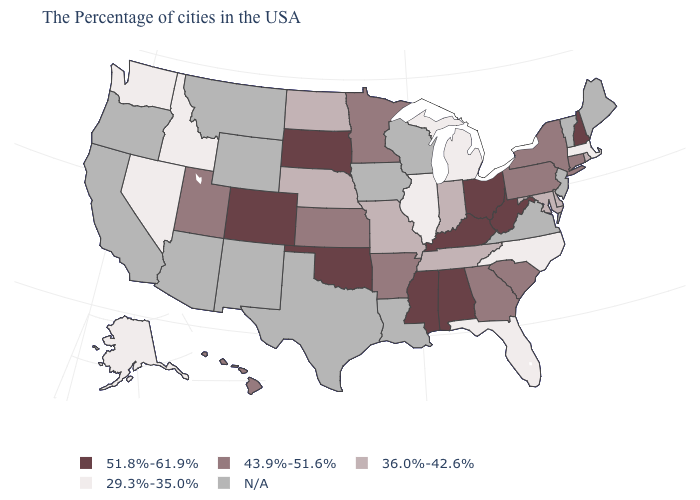Among the states that border South Dakota , does Minnesota have the highest value?
Answer briefly. Yes. What is the value of Ohio?
Keep it brief. 51.8%-61.9%. Does the map have missing data?
Concise answer only. Yes. What is the value of Alaska?
Quick response, please. 29.3%-35.0%. Among the states that border Texas , which have the lowest value?
Concise answer only. Arkansas. Name the states that have a value in the range 29.3%-35.0%?
Give a very brief answer. Massachusetts, North Carolina, Florida, Michigan, Illinois, Idaho, Nevada, Washington, Alaska. Name the states that have a value in the range 43.9%-51.6%?
Be succinct. Connecticut, New York, Pennsylvania, South Carolina, Georgia, Arkansas, Minnesota, Kansas, Utah, Hawaii. Does the map have missing data?
Short answer required. Yes. Name the states that have a value in the range 29.3%-35.0%?
Quick response, please. Massachusetts, North Carolina, Florida, Michigan, Illinois, Idaho, Nevada, Washington, Alaska. What is the value of Connecticut?
Short answer required. 43.9%-51.6%. Which states have the highest value in the USA?
Give a very brief answer. New Hampshire, West Virginia, Ohio, Kentucky, Alabama, Mississippi, Oklahoma, South Dakota, Colorado. What is the lowest value in states that border Florida?
Short answer required. 43.9%-51.6%. What is the lowest value in the MidWest?
Quick response, please. 29.3%-35.0%. 